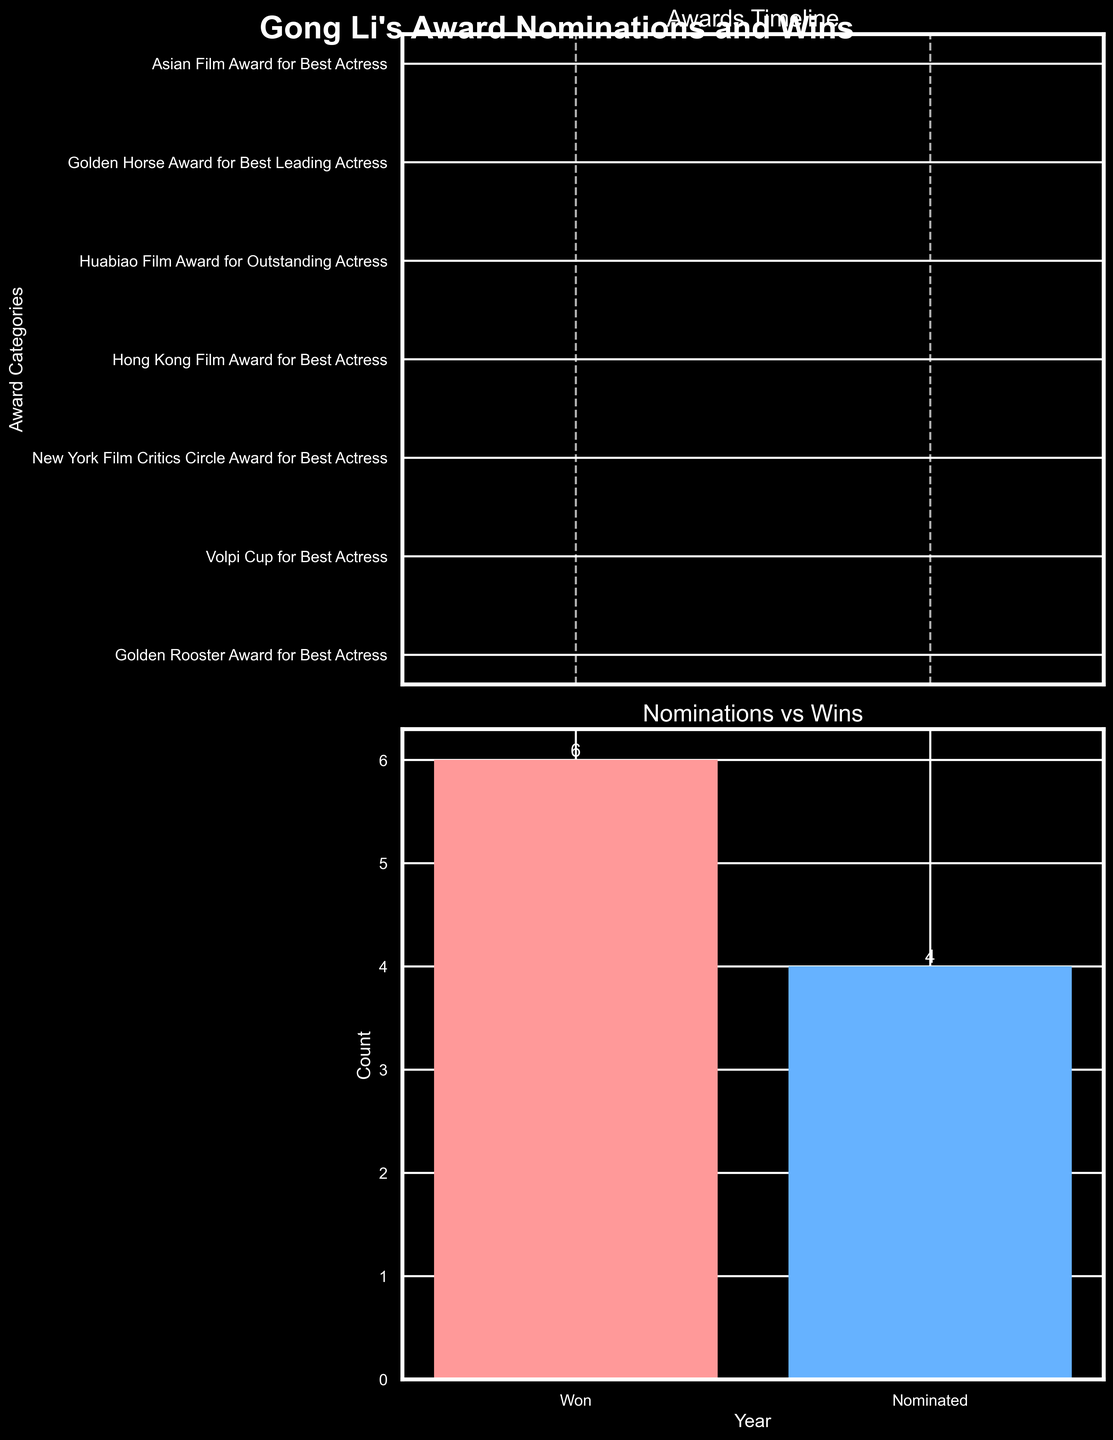What is the title of the figure? The figure's title is located at the top center and states the main subject of the figure.
Answer: Gong Li's Award Nominations and Wins How many total award categories are displayed in the timeline subplot? Count the number of distinct award categories listed on the y-axis of the timeline subplot.
Answer: 8 Which year did Gong Li receive the highest number of awards and nominations? Look for the year with the most markers (either circles for wins or Xs for nominations) in the timeline subplot.
Answer: 2005 How many times was Gong Li nominated but did not win an award? Check the second subplot that shows the comparison between nominations and wins by observing the bar heights and the numbers above them.
Answer: 4 Which category did Gong Li win an award for in both 1989 and 2019? Identify the two markers (one for 1989 and one for 2019) in the timeline subplot and check if they correspond to the same category.
Answer: Golden Rooster Award for Best Actress How many categories did Gong Li win at least once? Count the number of distinct categories with a circle marker in the timeline subplot.
Answer: 6 In which category was Gong Li nominated for the first time but did not win? Find the earliest year in the timeline subplot that has an "X" marker and note the corresponding category on the y-axis.
Answer: New York Film Critics Circle Award for Best Actress What is the total number of awards Gong Li has won according to the figure? Refer to the 'Nominations vs Wins' subplot and look at the value associated with the "Won" bar.
Answer: 6 Which award category has more nominations than wins? Compare the number of circle markers (wins) and X markers (nominations) in the timeline subplot for each category listed.
Answer: Asian Film Award for Best Actress Which decade shows the highest frequency of Gong Li's nominations and wins? Divide the years into decades and count the markers (circles and Xs) for each decade in the timeline subplot.
Answer: 2000s 